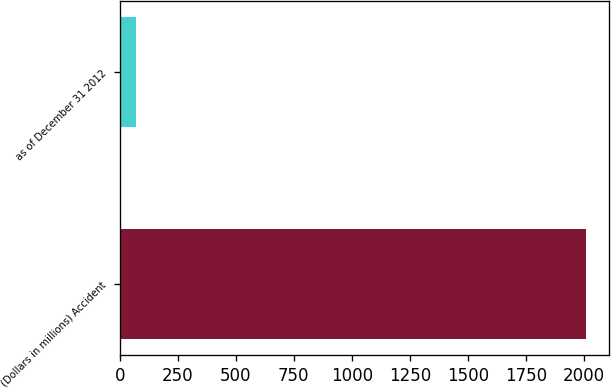<chart> <loc_0><loc_0><loc_500><loc_500><bar_chart><fcel>(Dollars in millions) Accident<fcel>as of December 31 2012<nl><fcel>2010<fcel>70<nl></chart> 